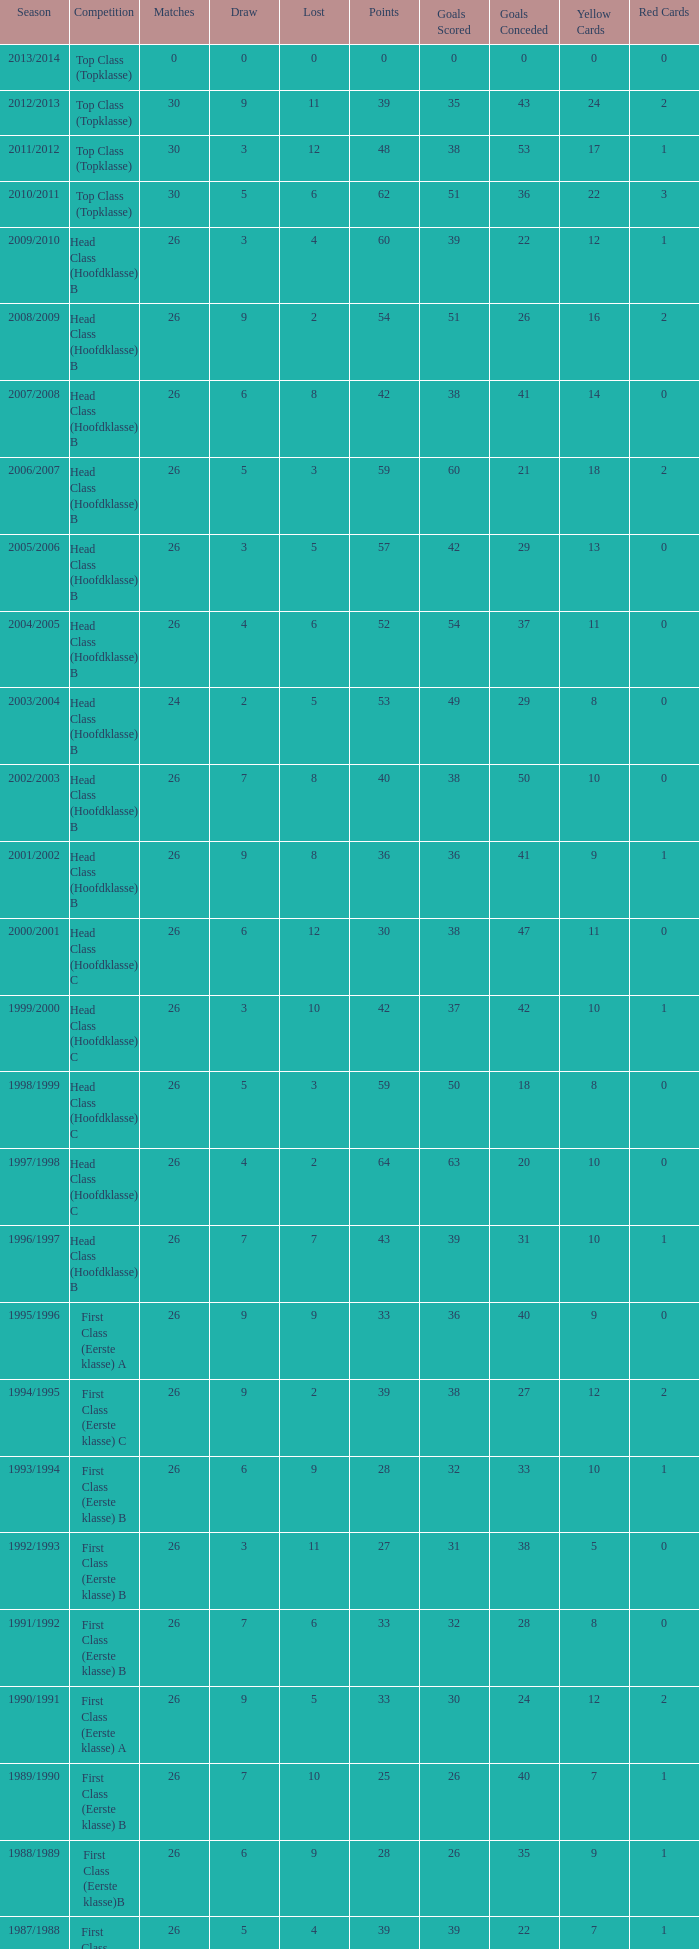What competition has a score greater than 30, a draw less than 5, and a loss larger than 10? Top Class (Topklasse). 